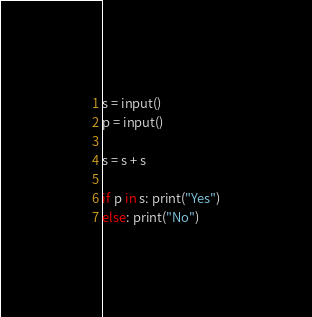<code> <loc_0><loc_0><loc_500><loc_500><_Python_>s = input()
p = input()

s = s + s

if p in s: print("Yes")
else: print("No")
</code> 